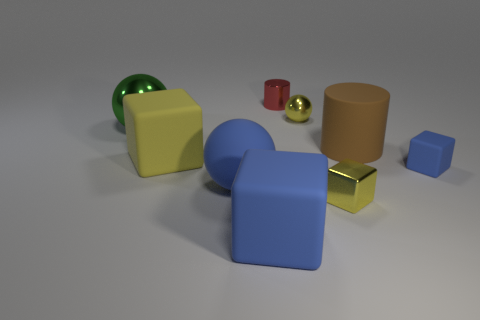How does the lighting in the scene affect the appearance of the objects? The lighting in the scene is soft and diffused, casting subtle shadows and highlighting the objects' colors and textures. It enhances the three-dimensionality of the objects and contributes to the overall calm and balanced composition of the image. 